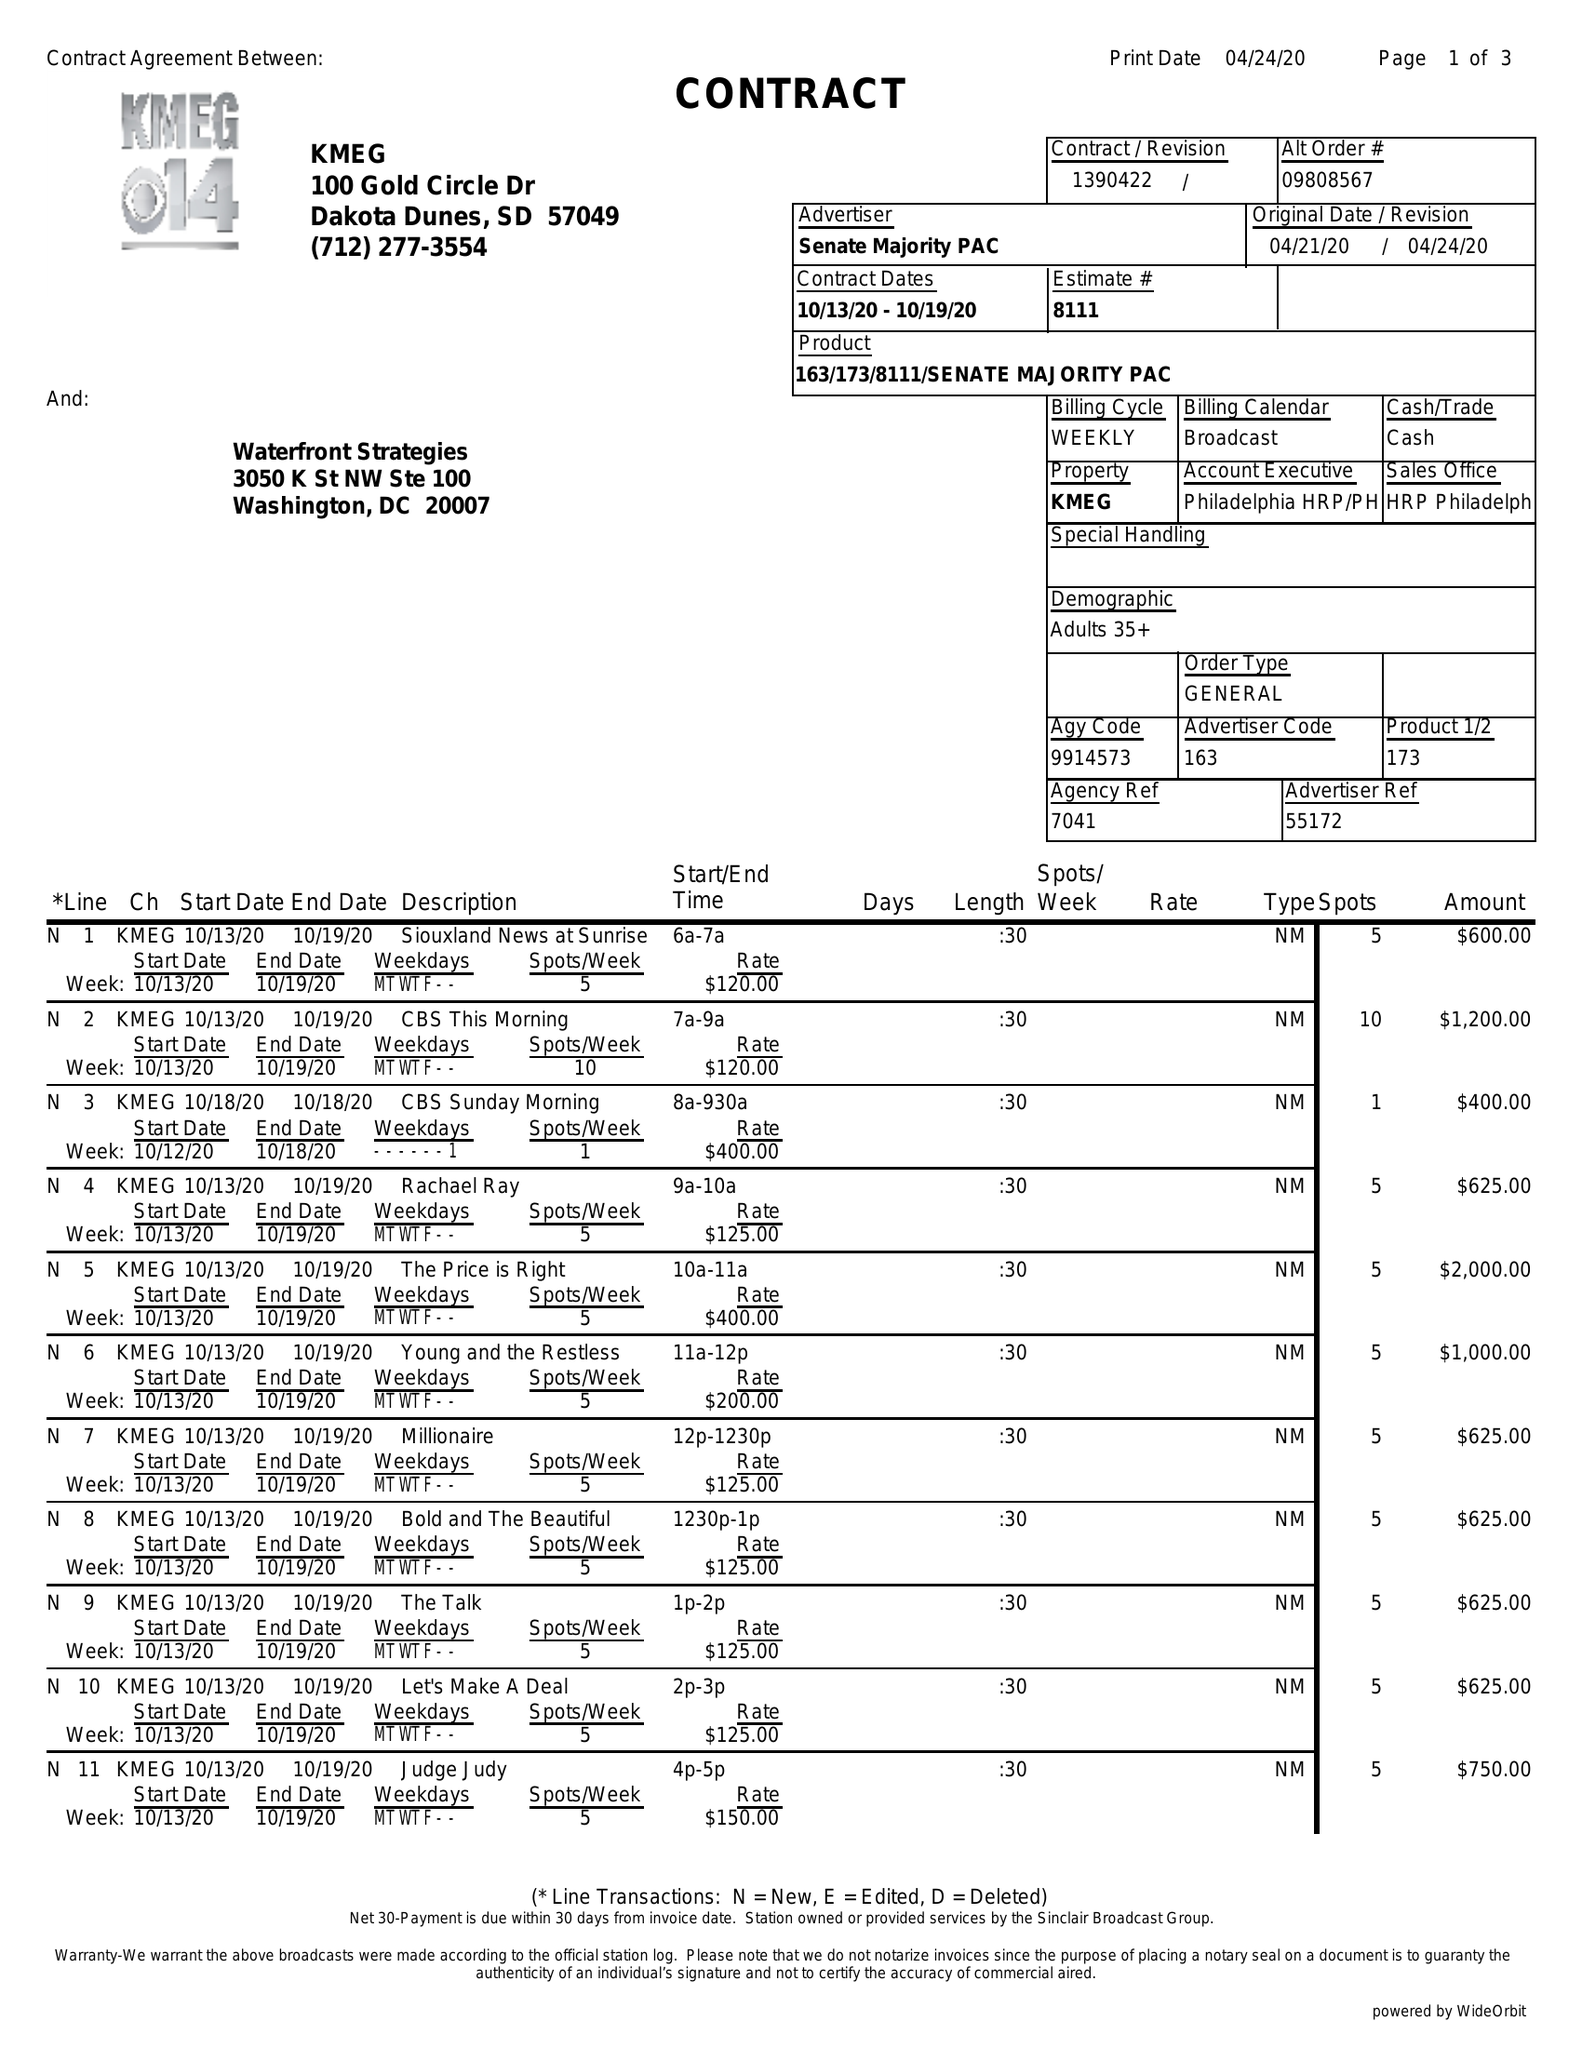What is the value for the advertiser?
Answer the question using a single word or phrase. SENATE MAJORITY PAC 